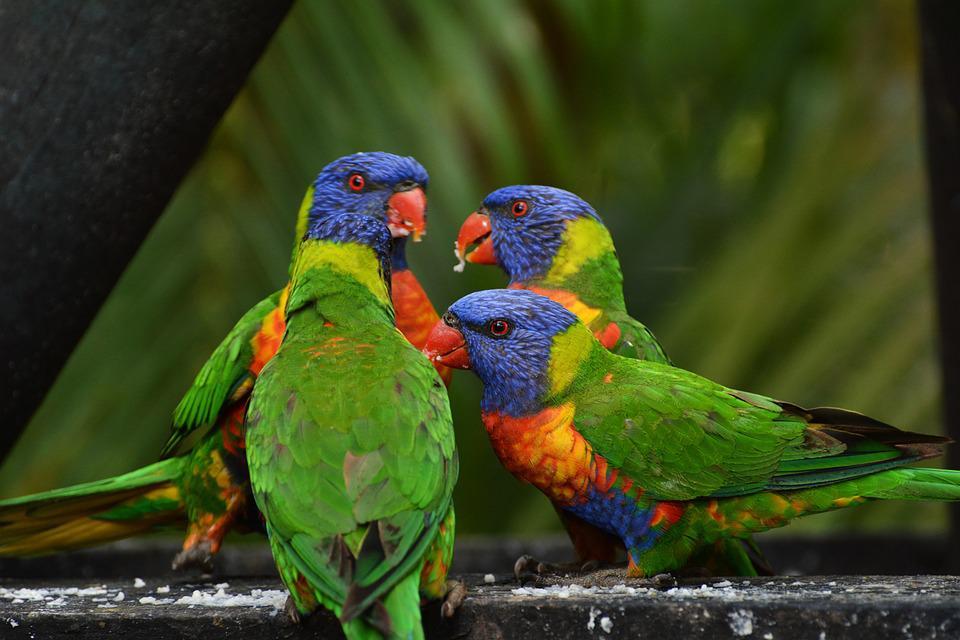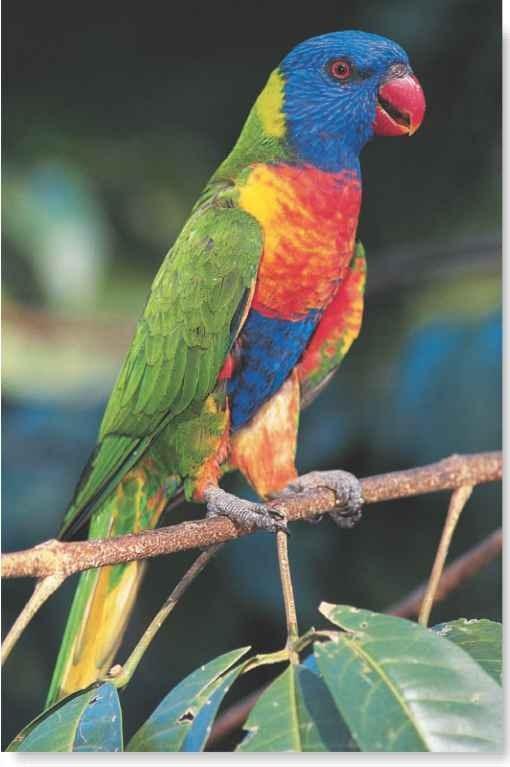The first image is the image on the left, the second image is the image on the right. Evaluate the accuracy of this statement regarding the images: "One image contains an entire flock of birds, 5 or more.". Is it true? Answer yes or no. No. The first image is the image on the left, the second image is the image on the right. Assess this claim about the two images: "One bird stands alone.". Correct or not? Answer yes or no. Yes. 